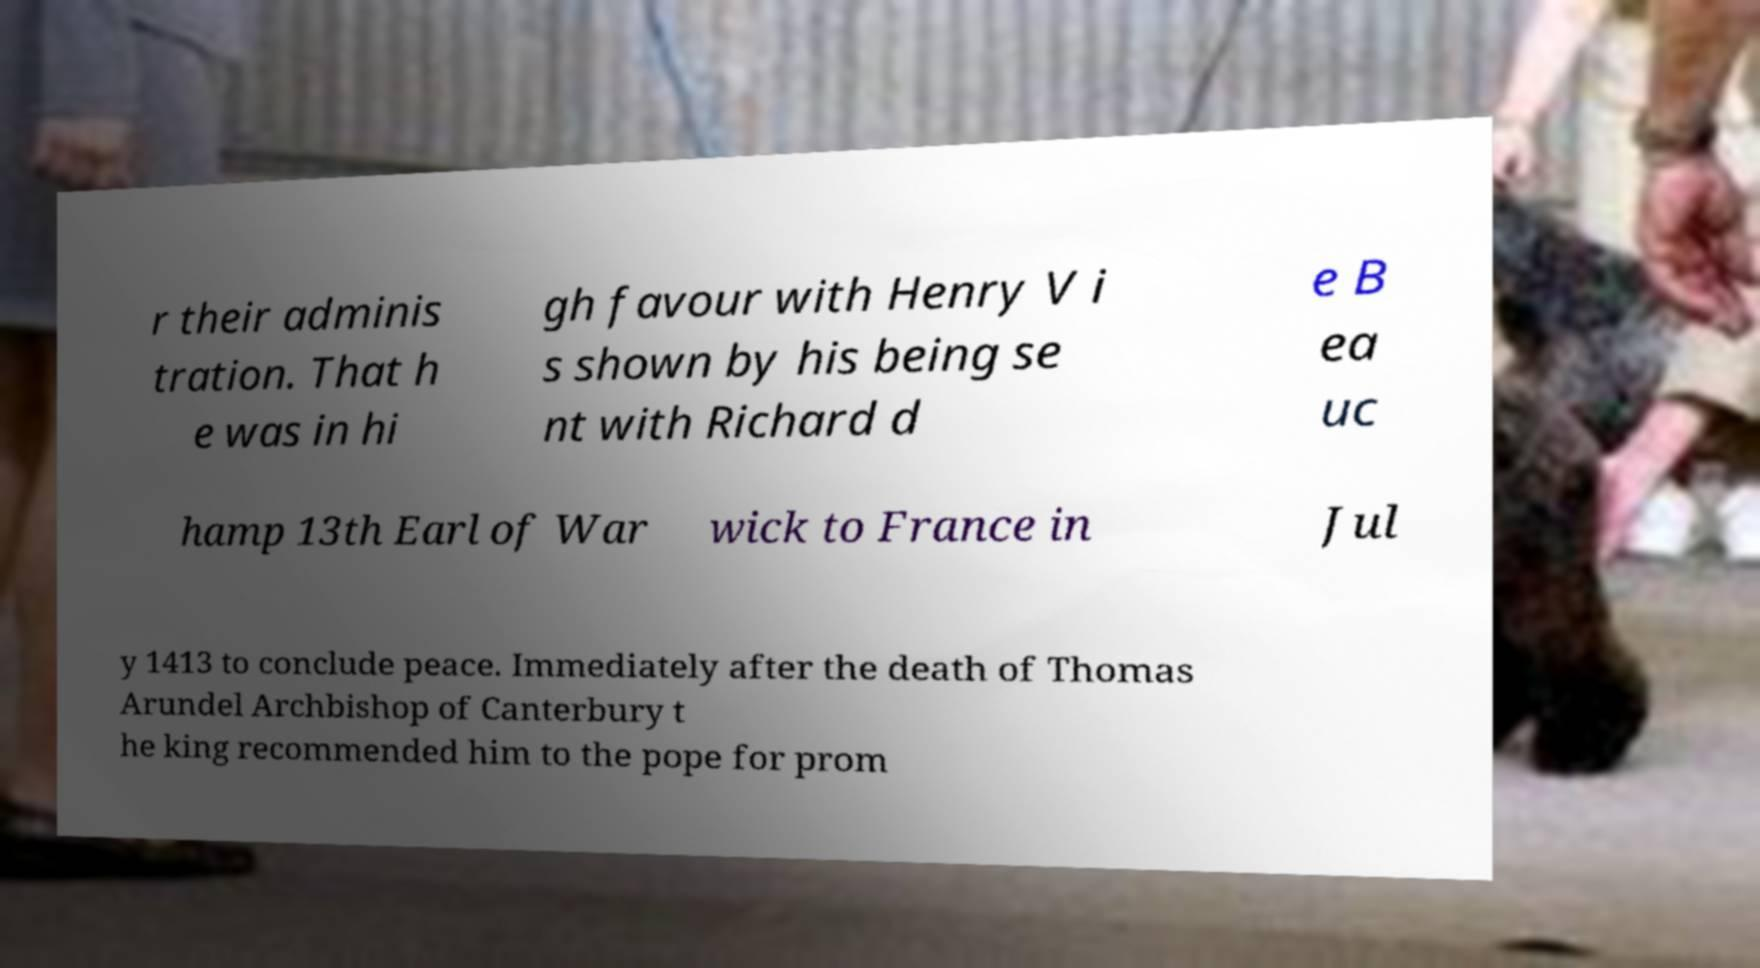There's text embedded in this image that I need extracted. Can you transcribe it verbatim? r their adminis tration. That h e was in hi gh favour with Henry V i s shown by his being se nt with Richard d e B ea uc hamp 13th Earl of War wick to France in Jul y 1413 to conclude peace. Immediately after the death of Thomas Arundel Archbishop of Canterbury t he king recommended him to the pope for prom 